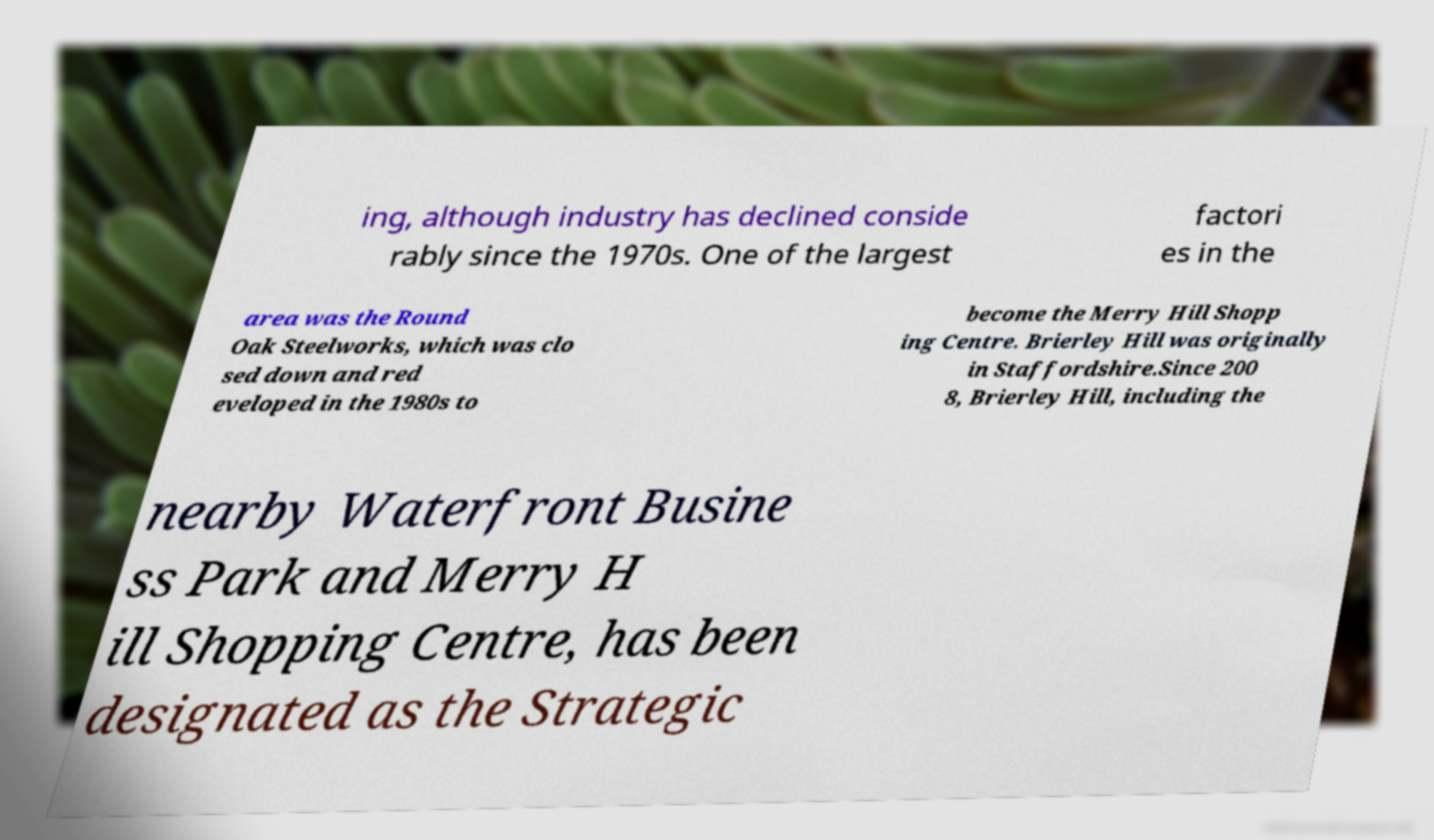Can you accurately transcribe the text from the provided image for me? ing, although industry has declined conside rably since the 1970s. One of the largest factori es in the area was the Round Oak Steelworks, which was clo sed down and red eveloped in the 1980s to become the Merry Hill Shopp ing Centre. Brierley Hill was originally in Staffordshire.Since 200 8, Brierley Hill, including the nearby Waterfront Busine ss Park and Merry H ill Shopping Centre, has been designated as the Strategic 